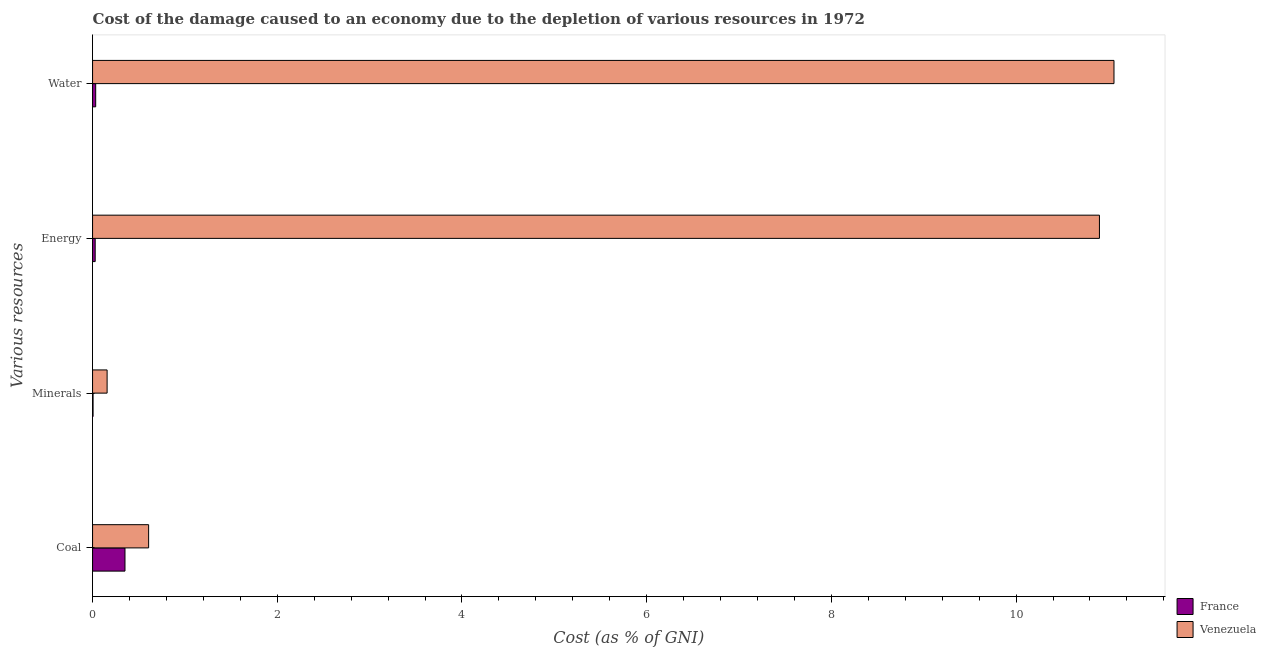How many different coloured bars are there?
Ensure brevity in your answer.  2. Are the number of bars per tick equal to the number of legend labels?
Give a very brief answer. Yes. Are the number of bars on each tick of the Y-axis equal?
Your answer should be very brief. Yes. How many bars are there on the 4th tick from the top?
Your answer should be very brief. 2. How many bars are there on the 2nd tick from the bottom?
Your response must be concise. 2. What is the label of the 3rd group of bars from the top?
Offer a very short reply. Minerals. What is the cost of damage due to depletion of coal in Venezuela?
Provide a succinct answer. 0.61. Across all countries, what is the maximum cost of damage due to depletion of energy?
Offer a very short reply. 10.9. Across all countries, what is the minimum cost of damage due to depletion of coal?
Keep it short and to the point. 0.35. In which country was the cost of damage due to depletion of energy maximum?
Offer a terse response. Venezuela. What is the total cost of damage due to depletion of minerals in the graph?
Ensure brevity in your answer.  0.16. What is the difference between the cost of damage due to depletion of energy in Venezuela and that in France?
Your answer should be very brief. 10.87. What is the difference between the cost of damage due to depletion of coal in France and the cost of damage due to depletion of energy in Venezuela?
Give a very brief answer. -10.55. What is the average cost of damage due to depletion of water per country?
Your answer should be compact. 5.55. What is the difference between the cost of damage due to depletion of coal and cost of damage due to depletion of water in Venezuela?
Make the answer very short. -10.45. What is the ratio of the cost of damage due to depletion of minerals in France to that in Venezuela?
Give a very brief answer. 0.03. What is the difference between the highest and the second highest cost of damage due to depletion of coal?
Keep it short and to the point. 0.26. What is the difference between the highest and the lowest cost of damage due to depletion of coal?
Make the answer very short. 0.26. Is the sum of the cost of damage due to depletion of coal in Venezuela and France greater than the maximum cost of damage due to depletion of energy across all countries?
Your answer should be compact. No. Is it the case that in every country, the sum of the cost of damage due to depletion of minerals and cost of damage due to depletion of coal is greater than the sum of cost of damage due to depletion of water and cost of damage due to depletion of energy?
Offer a very short reply. No. What does the 1st bar from the top in Energy represents?
Provide a short and direct response. Venezuela. How many bars are there?
Your response must be concise. 8. Are all the bars in the graph horizontal?
Ensure brevity in your answer.  Yes. How many countries are there in the graph?
Make the answer very short. 2. Are the values on the major ticks of X-axis written in scientific E-notation?
Your answer should be compact. No. Where does the legend appear in the graph?
Give a very brief answer. Bottom right. How are the legend labels stacked?
Your answer should be compact. Vertical. What is the title of the graph?
Give a very brief answer. Cost of the damage caused to an economy due to the depletion of various resources in 1972 . Does "St. Kitts and Nevis" appear as one of the legend labels in the graph?
Your answer should be compact. No. What is the label or title of the X-axis?
Your answer should be compact. Cost (as % of GNI). What is the label or title of the Y-axis?
Make the answer very short. Various resources. What is the Cost (as % of GNI) of France in Coal?
Offer a very short reply. 0.35. What is the Cost (as % of GNI) in Venezuela in Coal?
Provide a short and direct response. 0.61. What is the Cost (as % of GNI) in France in Minerals?
Your response must be concise. 0.01. What is the Cost (as % of GNI) in Venezuela in Minerals?
Offer a terse response. 0.16. What is the Cost (as % of GNI) in France in Energy?
Keep it short and to the point. 0.03. What is the Cost (as % of GNI) of Venezuela in Energy?
Keep it short and to the point. 10.9. What is the Cost (as % of GNI) of France in Water?
Your response must be concise. 0.03. What is the Cost (as % of GNI) of Venezuela in Water?
Ensure brevity in your answer.  11.06. Across all Various resources, what is the maximum Cost (as % of GNI) of France?
Keep it short and to the point. 0.35. Across all Various resources, what is the maximum Cost (as % of GNI) in Venezuela?
Ensure brevity in your answer.  11.06. Across all Various resources, what is the minimum Cost (as % of GNI) in France?
Give a very brief answer. 0.01. Across all Various resources, what is the minimum Cost (as % of GNI) of Venezuela?
Provide a succinct answer. 0.16. What is the total Cost (as % of GNI) in France in the graph?
Provide a short and direct response. 0.42. What is the total Cost (as % of GNI) in Venezuela in the graph?
Give a very brief answer. 22.73. What is the difference between the Cost (as % of GNI) of France in Coal and that in Minerals?
Offer a terse response. 0.35. What is the difference between the Cost (as % of GNI) in Venezuela in Coal and that in Minerals?
Offer a very short reply. 0.45. What is the difference between the Cost (as % of GNI) of France in Coal and that in Energy?
Make the answer very short. 0.32. What is the difference between the Cost (as % of GNI) in Venezuela in Coal and that in Energy?
Make the answer very short. -10.3. What is the difference between the Cost (as % of GNI) of France in Coal and that in Water?
Provide a short and direct response. 0.32. What is the difference between the Cost (as % of GNI) of Venezuela in Coal and that in Water?
Ensure brevity in your answer.  -10.45. What is the difference between the Cost (as % of GNI) in France in Minerals and that in Energy?
Offer a terse response. -0.02. What is the difference between the Cost (as % of GNI) in Venezuela in Minerals and that in Energy?
Your answer should be compact. -10.75. What is the difference between the Cost (as % of GNI) of France in Minerals and that in Water?
Ensure brevity in your answer.  -0.03. What is the difference between the Cost (as % of GNI) in Venezuela in Minerals and that in Water?
Your answer should be very brief. -10.9. What is the difference between the Cost (as % of GNI) of France in Energy and that in Water?
Your answer should be very brief. -0.01. What is the difference between the Cost (as % of GNI) of Venezuela in Energy and that in Water?
Make the answer very short. -0.16. What is the difference between the Cost (as % of GNI) of France in Coal and the Cost (as % of GNI) of Venezuela in Minerals?
Keep it short and to the point. 0.19. What is the difference between the Cost (as % of GNI) in France in Coal and the Cost (as % of GNI) in Venezuela in Energy?
Keep it short and to the point. -10.55. What is the difference between the Cost (as % of GNI) in France in Coal and the Cost (as % of GNI) in Venezuela in Water?
Provide a short and direct response. -10.71. What is the difference between the Cost (as % of GNI) in France in Minerals and the Cost (as % of GNI) in Venezuela in Energy?
Offer a very short reply. -10.9. What is the difference between the Cost (as % of GNI) in France in Minerals and the Cost (as % of GNI) in Venezuela in Water?
Offer a very short reply. -11.05. What is the difference between the Cost (as % of GNI) in France in Energy and the Cost (as % of GNI) in Venezuela in Water?
Keep it short and to the point. -11.03. What is the average Cost (as % of GNI) in France per Various resources?
Ensure brevity in your answer.  0.1. What is the average Cost (as % of GNI) of Venezuela per Various resources?
Your answer should be very brief. 5.68. What is the difference between the Cost (as % of GNI) of France and Cost (as % of GNI) of Venezuela in Coal?
Your answer should be very brief. -0.26. What is the difference between the Cost (as % of GNI) of France and Cost (as % of GNI) of Venezuela in Minerals?
Make the answer very short. -0.15. What is the difference between the Cost (as % of GNI) of France and Cost (as % of GNI) of Venezuela in Energy?
Your response must be concise. -10.87. What is the difference between the Cost (as % of GNI) of France and Cost (as % of GNI) of Venezuela in Water?
Provide a succinct answer. -11.03. What is the ratio of the Cost (as % of GNI) in France in Coal to that in Minerals?
Your answer should be compact. 64.49. What is the ratio of the Cost (as % of GNI) of Venezuela in Coal to that in Minerals?
Provide a succinct answer. 3.85. What is the ratio of the Cost (as % of GNI) in France in Coal to that in Energy?
Provide a succinct answer. 12.38. What is the ratio of the Cost (as % of GNI) of Venezuela in Coal to that in Energy?
Provide a succinct answer. 0.06. What is the ratio of the Cost (as % of GNI) of France in Coal to that in Water?
Offer a terse response. 10.39. What is the ratio of the Cost (as % of GNI) of Venezuela in Coal to that in Water?
Ensure brevity in your answer.  0.05. What is the ratio of the Cost (as % of GNI) of France in Minerals to that in Energy?
Your response must be concise. 0.19. What is the ratio of the Cost (as % of GNI) of Venezuela in Minerals to that in Energy?
Ensure brevity in your answer.  0.01. What is the ratio of the Cost (as % of GNI) in France in Minerals to that in Water?
Provide a succinct answer. 0.16. What is the ratio of the Cost (as % of GNI) in Venezuela in Minerals to that in Water?
Give a very brief answer. 0.01. What is the ratio of the Cost (as % of GNI) in France in Energy to that in Water?
Offer a very short reply. 0.84. What is the ratio of the Cost (as % of GNI) of Venezuela in Energy to that in Water?
Offer a terse response. 0.99. What is the difference between the highest and the second highest Cost (as % of GNI) of France?
Give a very brief answer. 0.32. What is the difference between the highest and the second highest Cost (as % of GNI) of Venezuela?
Your answer should be very brief. 0.16. What is the difference between the highest and the lowest Cost (as % of GNI) of France?
Provide a succinct answer. 0.35. What is the difference between the highest and the lowest Cost (as % of GNI) in Venezuela?
Give a very brief answer. 10.9. 